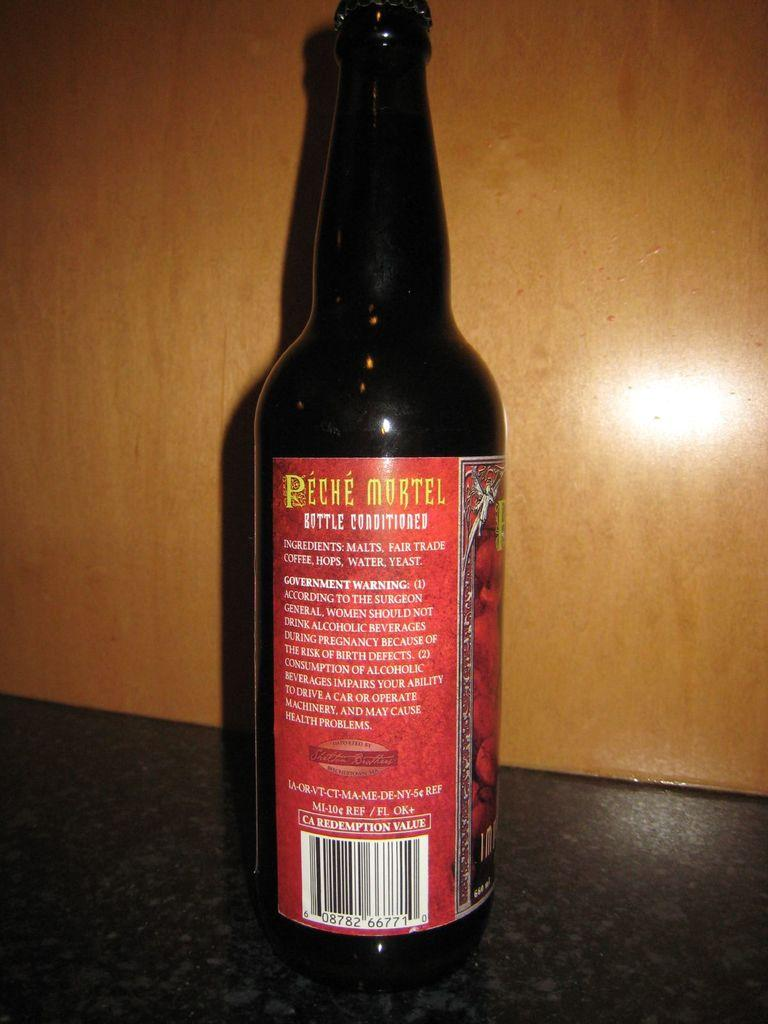<image>
Render a clear and concise summary of the photo. A bottle on a counter top that shows the back of the label called Peche Mortel. 